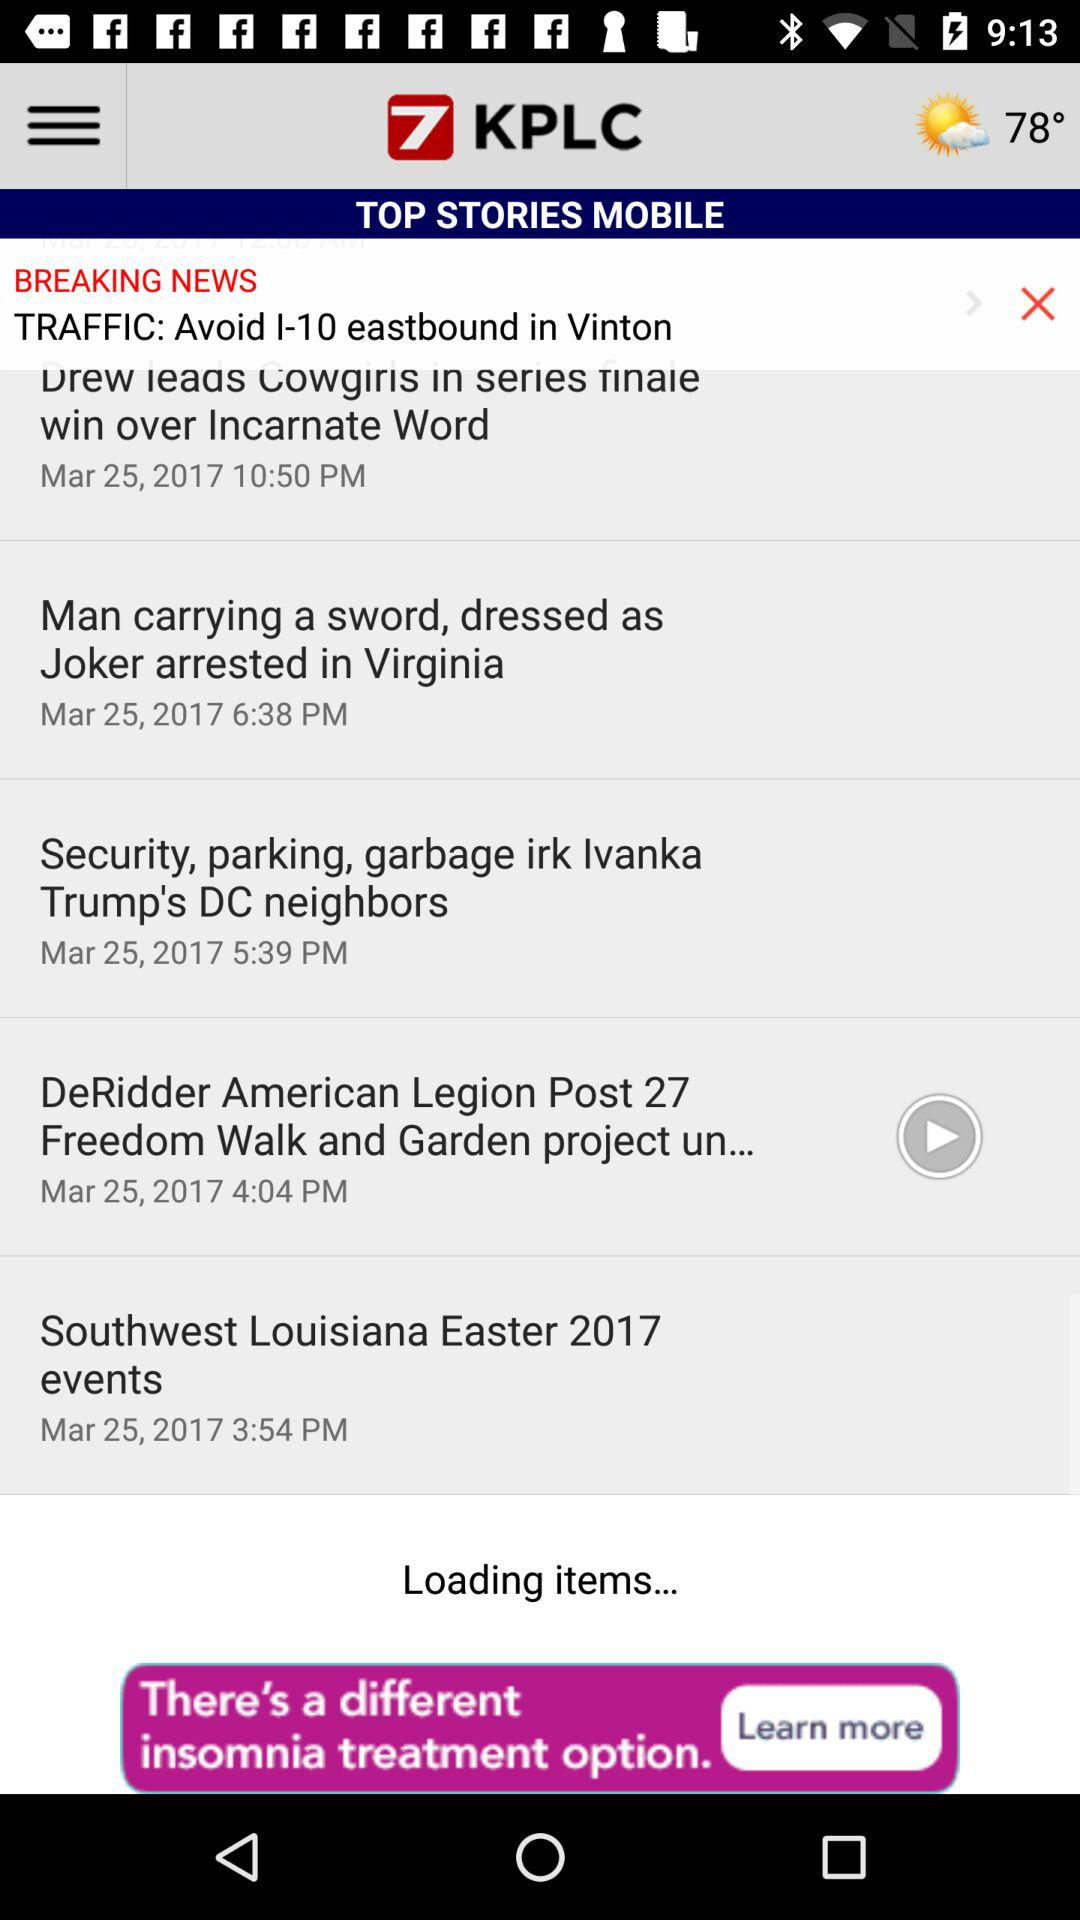Will tomorrow be sunny?
When the provided information is insufficient, respond with <no answer>. <no answer> 